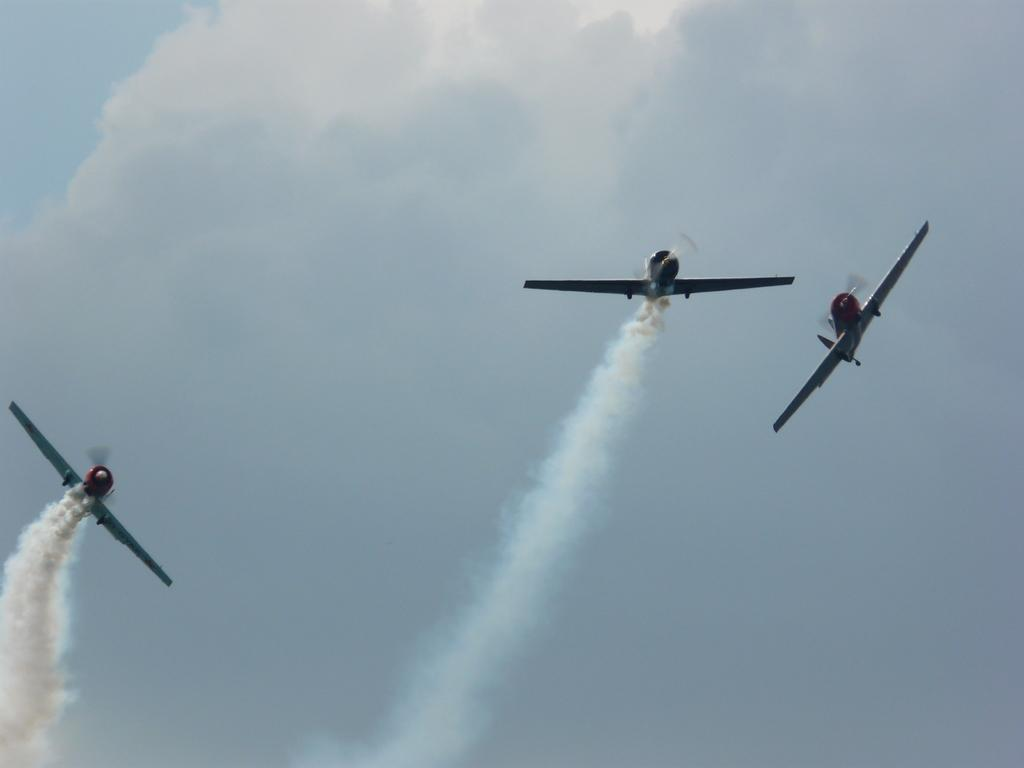How many planes can be seen in the image? There are three planes in the image. What are the planes doing in the image? The planes are flying in the air. What can be seen coming out of the planes in the image? There is white-colored fume visible in the image. What is visible in the background of the image? The sky is visible in the image. What is the color of the sky in the image? The color of the sky is blue. How much money is the achiever holding in the image? There is no achiever or money present in the image; it features three planes flying in the air. What type of range can be seen in the image? There is no range present in the image; it features three planes flying in the air and a blue sky. 